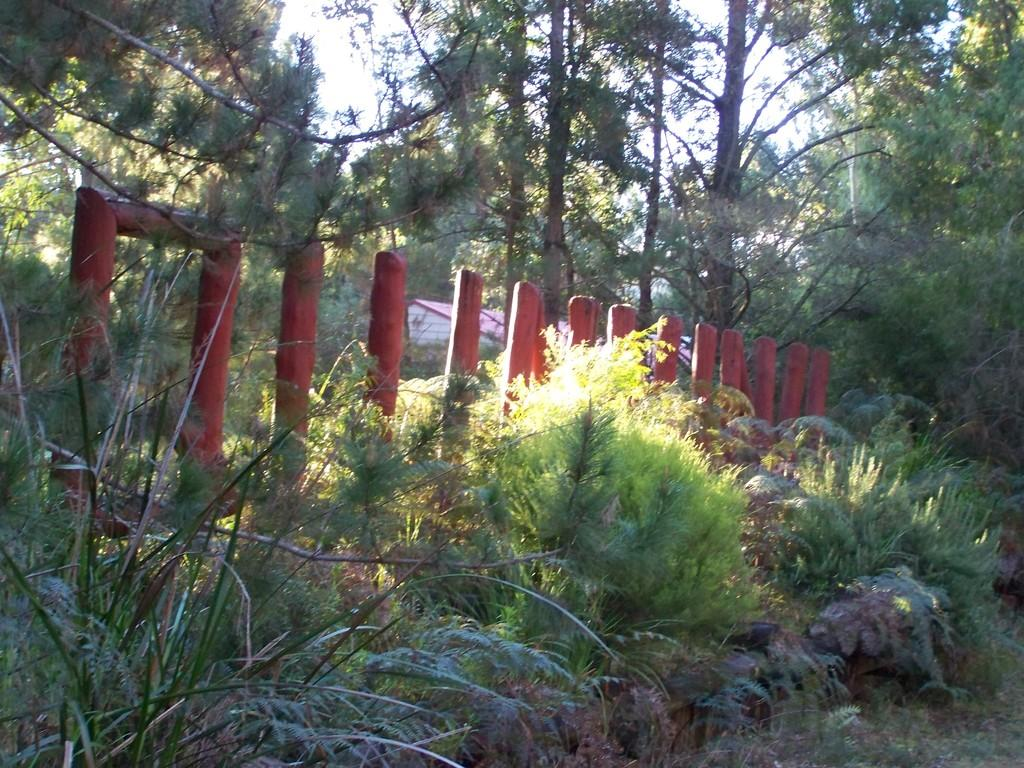What type of structure is visible in the image? There is a house in the image. What type of vegetation is present can be seen in the image? There are trees and plants visible in the image. What is the foreground of the image composed of? The foreground of the image includes a railing and plants. What is visible at the top of the image? The sky is visible at the top of the image. What type of ground cover is present at the bottom of the image? Grass is present at the bottom of the image. What type of range is visible in the image? There is no range present in the image. What type of offer is being made by the house in the image? The image does not depict any offers being made by the house. 